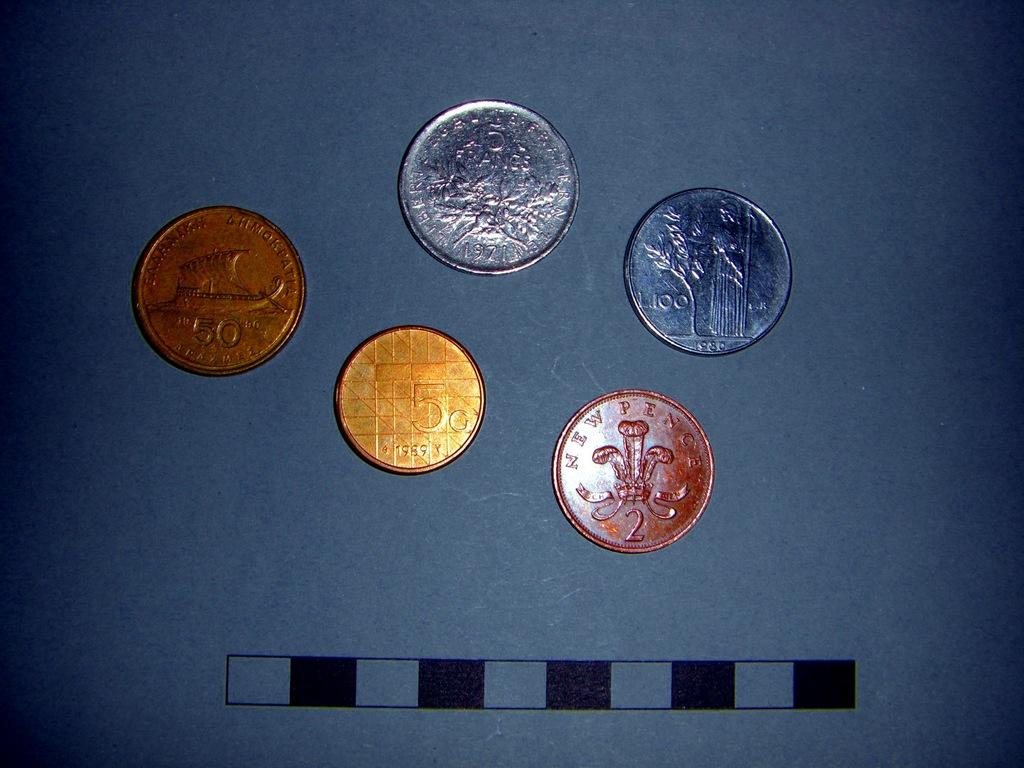What is the value of any of these coins?
Give a very brief answer. 5c. What does the red coin say?
Your answer should be very brief. New pence. 